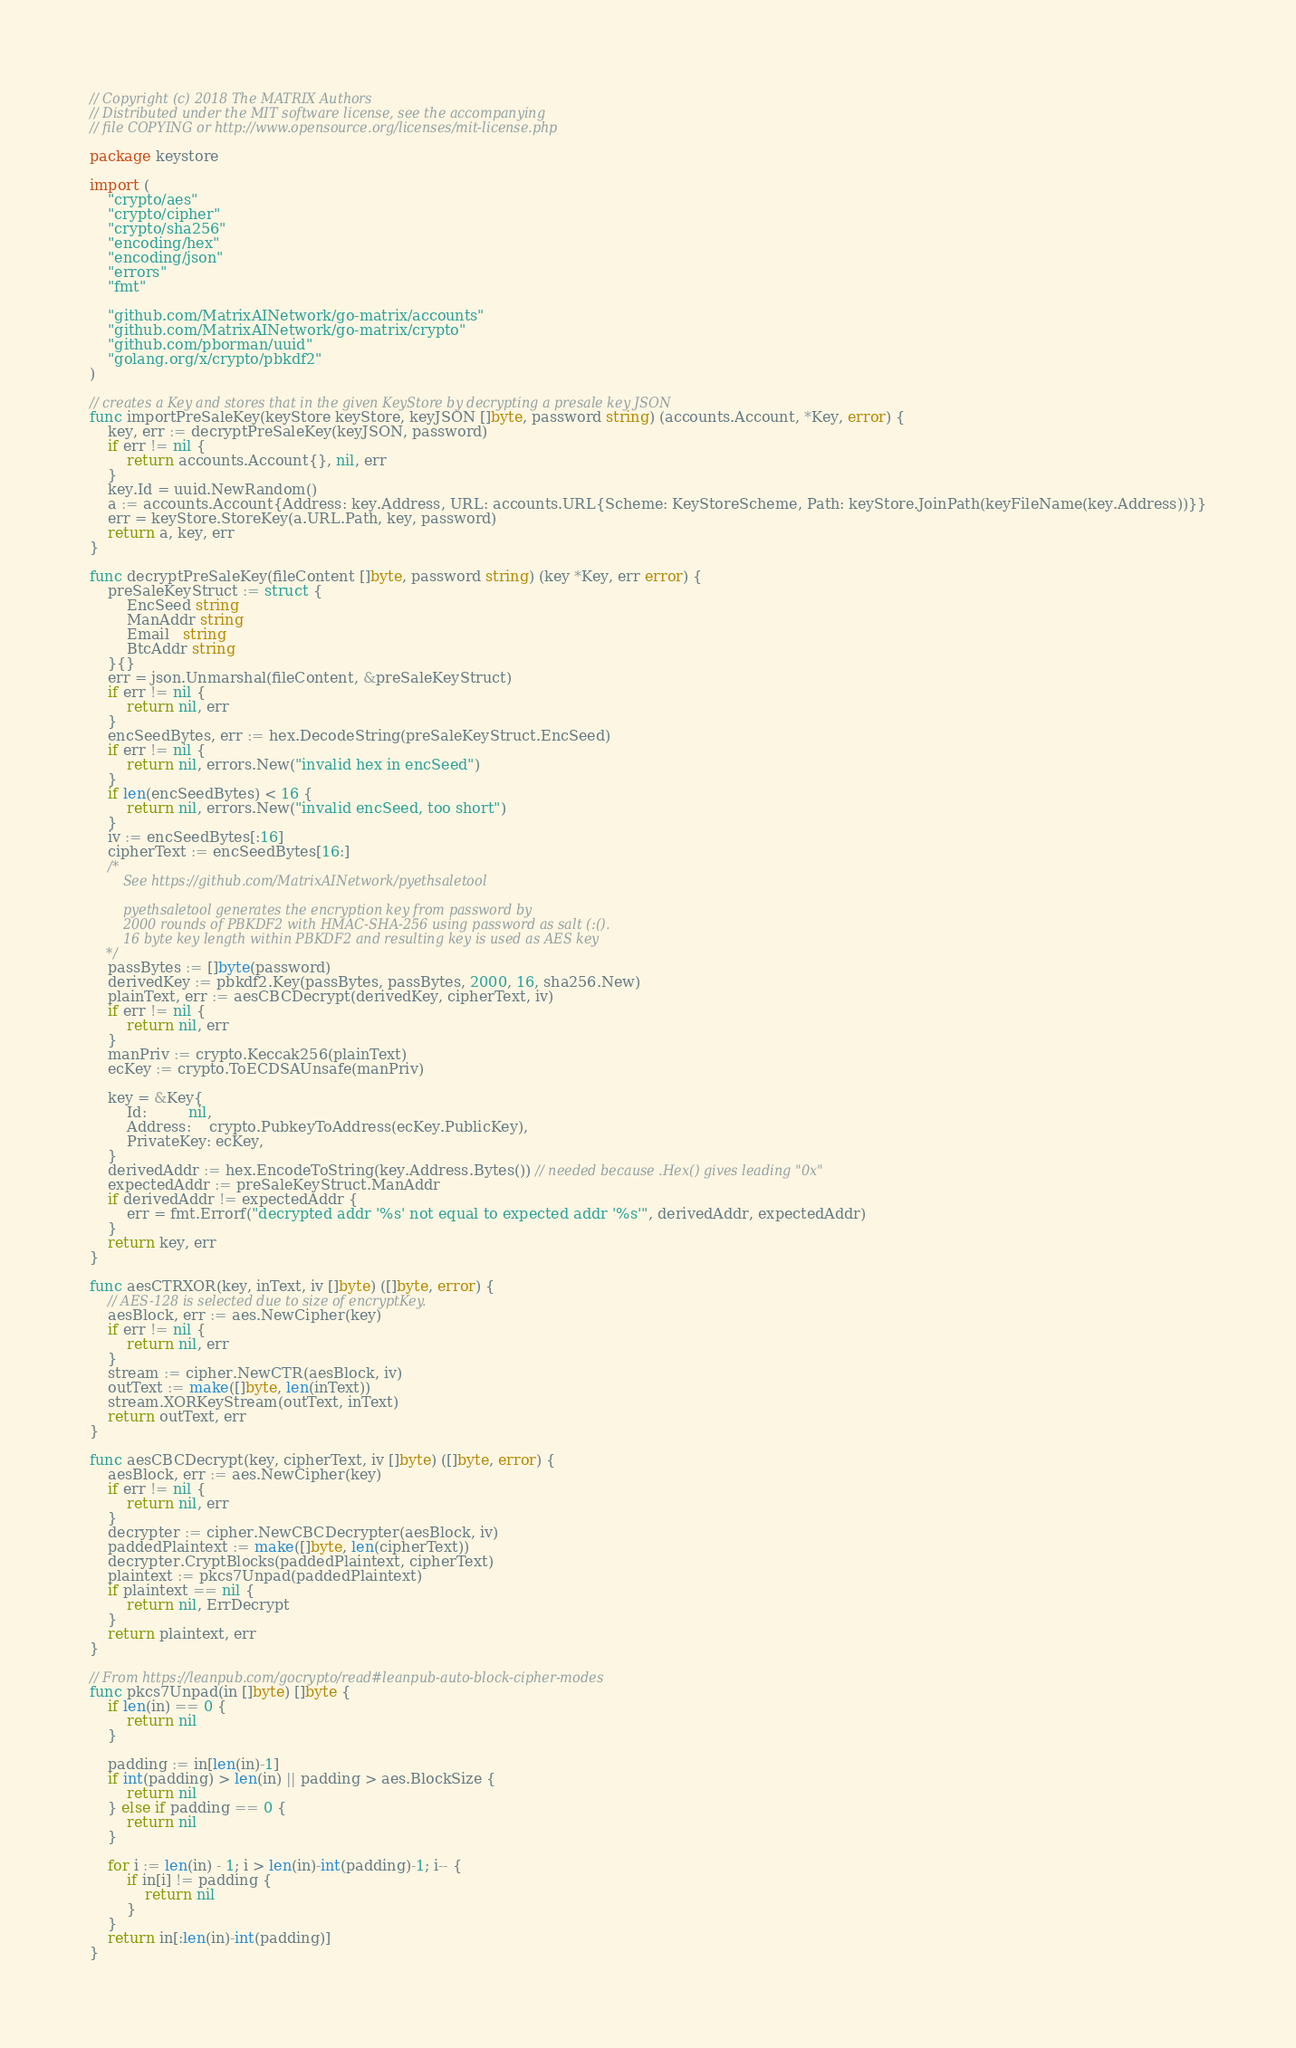Convert code to text. <code><loc_0><loc_0><loc_500><loc_500><_Go_>// Copyright (c) 2018 The MATRIX Authors
// Distributed under the MIT software license, see the accompanying
// file COPYING or http://www.opensource.org/licenses/mit-license.php

package keystore

import (
	"crypto/aes"
	"crypto/cipher"
	"crypto/sha256"
	"encoding/hex"
	"encoding/json"
	"errors"
	"fmt"

	"github.com/MatrixAINetwork/go-matrix/accounts"
	"github.com/MatrixAINetwork/go-matrix/crypto"
	"github.com/pborman/uuid"
	"golang.org/x/crypto/pbkdf2"
)

// creates a Key and stores that in the given KeyStore by decrypting a presale key JSON
func importPreSaleKey(keyStore keyStore, keyJSON []byte, password string) (accounts.Account, *Key, error) {
	key, err := decryptPreSaleKey(keyJSON, password)
	if err != nil {
		return accounts.Account{}, nil, err
	}
	key.Id = uuid.NewRandom()
	a := accounts.Account{Address: key.Address, URL: accounts.URL{Scheme: KeyStoreScheme, Path: keyStore.JoinPath(keyFileName(key.Address))}}
	err = keyStore.StoreKey(a.URL.Path, key, password)
	return a, key, err
}

func decryptPreSaleKey(fileContent []byte, password string) (key *Key, err error) {
	preSaleKeyStruct := struct {
		EncSeed string
		ManAddr string
		Email   string
		BtcAddr string
	}{}
	err = json.Unmarshal(fileContent, &preSaleKeyStruct)
	if err != nil {
		return nil, err
	}
	encSeedBytes, err := hex.DecodeString(preSaleKeyStruct.EncSeed)
	if err != nil {
		return nil, errors.New("invalid hex in encSeed")
	}
	if len(encSeedBytes) < 16 {
		return nil, errors.New("invalid encSeed, too short")
	}
	iv := encSeedBytes[:16]
	cipherText := encSeedBytes[16:]
	/*
		See https://github.com/MatrixAINetwork/pyethsaletool

		pyethsaletool generates the encryption key from password by
		2000 rounds of PBKDF2 with HMAC-SHA-256 using password as salt (:().
		16 byte key length within PBKDF2 and resulting key is used as AES key
	*/
	passBytes := []byte(password)
	derivedKey := pbkdf2.Key(passBytes, passBytes, 2000, 16, sha256.New)
	plainText, err := aesCBCDecrypt(derivedKey, cipherText, iv)
	if err != nil {
		return nil, err
	}
	manPriv := crypto.Keccak256(plainText)
	ecKey := crypto.ToECDSAUnsafe(manPriv)

	key = &Key{
		Id:         nil,
		Address:    crypto.PubkeyToAddress(ecKey.PublicKey),
		PrivateKey: ecKey,
	}
	derivedAddr := hex.EncodeToString(key.Address.Bytes()) // needed because .Hex() gives leading "0x"
	expectedAddr := preSaleKeyStruct.ManAddr
	if derivedAddr != expectedAddr {
		err = fmt.Errorf("decrypted addr '%s' not equal to expected addr '%s'", derivedAddr, expectedAddr)
	}
	return key, err
}

func aesCTRXOR(key, inText, iv []byte) ([]byte, error) {
	// AES-128 is selected due to size of encryptKey.
	aesBlock, err := aes.NewCipher(key)
	if err != nil {
		return nil, err
	}
	stream := cipher.NewCTR(aesBlock, iv)
	outText := make([]byte, len(inText))
	stream.XORKeyStream(outText, inText)
	return outText, err
}

func aesCBCDecrypt(key, cipherText, iv []byte) ([]byte, error) {
	aesBlock, err := aes.NewCipher(key)
	if err != nil {
		return nil, err
	}
	decrypter := cipher.NewCBCDecrypter(aesBlock, iv)
	paddedPlaintext := make([]byte, len(cipherText))
	decrypter.CryptBlocks(paddedPlaintext, cipherText)
	plaintext := pkcs7Unpad(paddedPlaintext)
	if plaintext == nil {
		return nil, ErrDecrypt
	}
	return plaintext, err
}

// From https://leanpub.com/gocrypto/read#leanpub-auto-block-cipher-modes
func pkcs7Unpad(in []byte) []byte {
	if len(in) == 0 {
		return nil
	}

	padding := in[len(in)-1]
	if int(padding) > len(in) || padding > aes.BlockSize {
		return nil
	} else if padding == 0 {
		return nil
	}

	for i := len(in) - 1; i > len(in)-int(padding)-1; i-- {
		if in[i] != padding {
			return nil
		}
	}
	return in[:len(in)-int(padding)]
}
</code> 